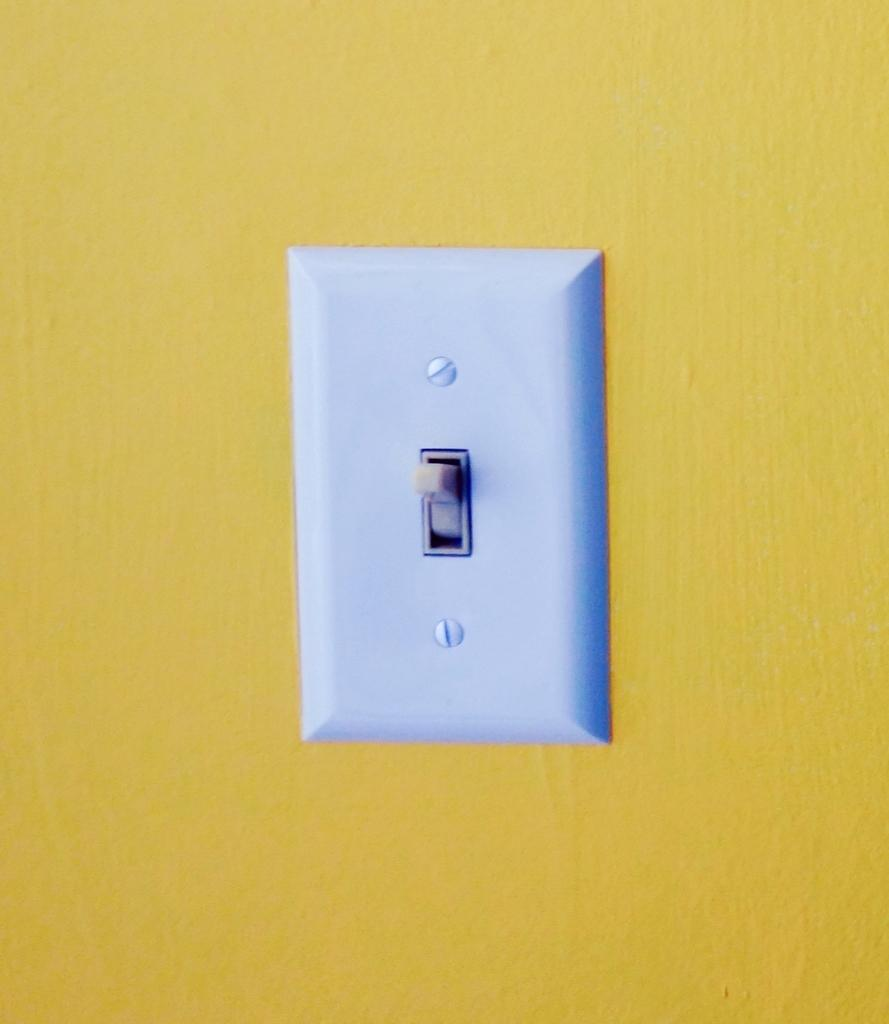What is the color of the switch in the image? The switch in the image is white-colored. What is the color of the wall on which the switch is mounted? The wall is in yellow color. How many servants are present in the image? There is no mention of servants in the image; it only features a white-colored switch on a yellow wall. 